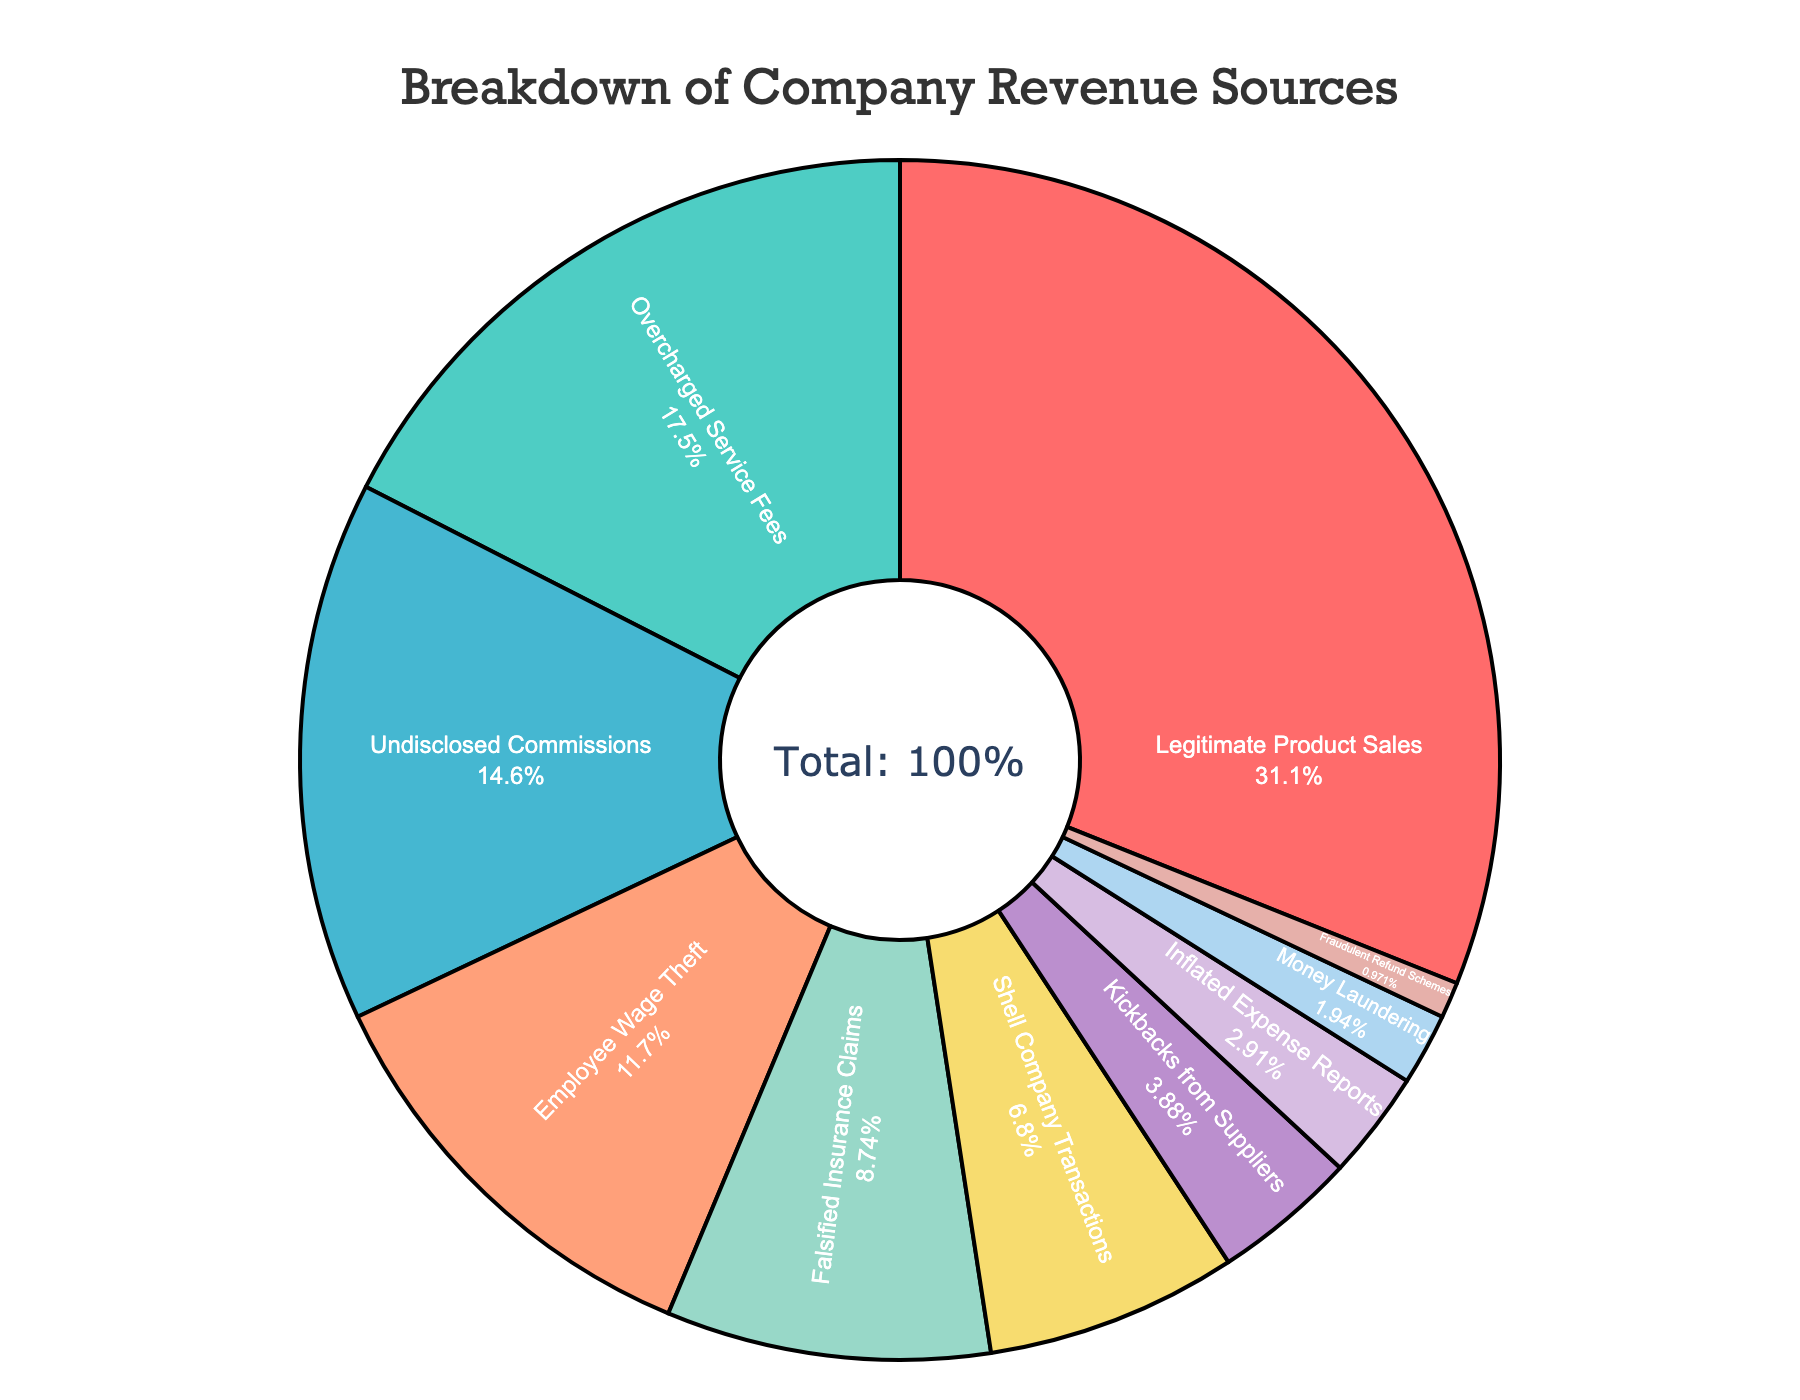What percentage of revenue comes from legitimate sources? Legitimate sources here refer only to "Legitimate Product Sales," which is 32%.
Answer: 32% What is the combined percentage of revenue coming from 'Overcharged Service Fees' and 'Undisclosed Commissions'? To find the combined percentage, we add 18% from 'Overcharged Service Fees' and 15% from 'Undisclosed Commissions'. 18% + 15% = 33%.
Answer: 33% Which fraudulent activity contributes the highest percentage to the revenue? The fraudulent activity with the highest percentage is 'Overcharged Service Fees' at 18%.
Answer: Overcharged Service Fees How does the percentage of 'Employee Wage Theft' compare to 'Falsified Insurance Claims'? 'Employee Wage Theft' is 12% and 'Falsified Insurance Claims' is 9%. 12% is greater than 9%.
Answer: Employee Wage Theft is greater List the revenue sources that contribute less than 5% individually. The revenue sources contributing less than 5% are 'Kickbacks from Suppliers' (4%), 'Inflated Expense Reports' (3%), 'Money Laundering' (2%), and 'Fraudulent Refund Schemes' (1%).
Answer: Kickbacks from Suppliers, Inflated Expense Reports, Money Laundering, Fraudulent Refund Schemes What is the average percentage contribution of 'Shell Company Transactions' and 'Kickbacks from Suppliers'? The percentages are 7% and 4%, respectively. The average is calculated as (7% + 4%) / 2 = 11% / 2 = 5.5%.
Answer: 5.5% Which revenue source(s) contributes exactly half of the percentage of 'Legitimate Product Sales'? 'Legitimate Product Sales' contributes 32%. Half of that is 16%. The only source close but recognized fractionally less is 'Undisclosed Commissions' with 15%.
Answer: 'Undisclosed Commissions' is the nearest Compare the combined percentages of 'Inflated Expense Reports' and 'Money Laundering' to 'Employee Wage Theft'. 'Inflated Expense Reports' is 3% and 'Money Laundering' is 2%, their sum is 5%. 'Employee Wage Theft' is 12%. 5% is less than 12%.
Answer: Combined is less Which revenue sources together add up to 25%? The best combination that adds up to 25% involves several complex steps. 'Employee Wage Theft' (12%), 'Falsified Insurance Claims' (9%), and 'Fraudulent Refund Schemes' (1%) total 22%. If you add the smallest step fitting addition, 'Kickbacks' (4%), it slightly overshoots. Thus, you need crafted selection or it's not directly exact to fit cleanly to 25%. Logically, it may mark transactional totals contributing small composites together.
Answer: Employee Wage Theft, Falsified Insurance Claims, Fraudelent Refund, some fraction 